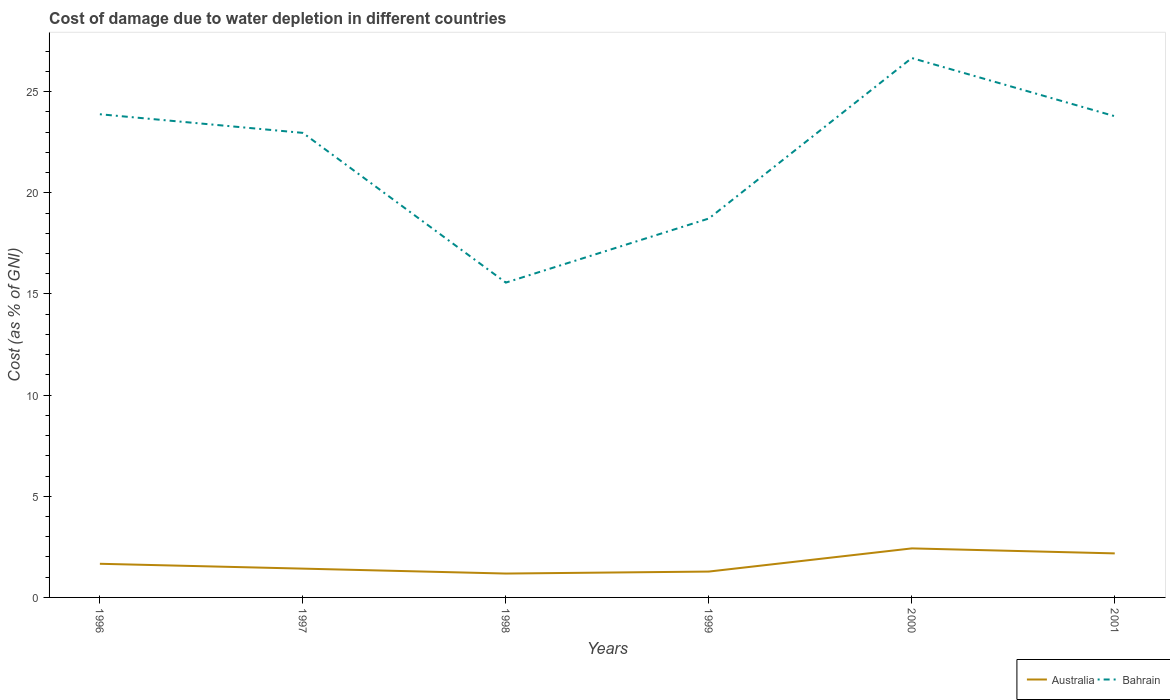How many different coloured lines are there?
Your answer should be compact. 2. Is the number of lines equal to the number of legend labels?
Give a very brief answer. Yes. Across all years, what is the maximum cost of damage caused due to water depletion in Australia?
Your response must be concise. 1.18. In which year was the cost of damage caused due to water depletion in Australia maximum?
Make the answer very short. 1998. What is the total cost of damage caused due to water depletion in Bahrain in the graph?
Keep it short and to the point. 0.92. What is the difference between the highest and the second highest cost of damage caused due to water depletion in Australia?
Give a very brief answer. 1.24. What is the difference between the highest and the lowest cost of damage caused due to water depletion in Bahrain?
Offer a terse response. 4. Is the cost of damage caused due to water depletion in Australia strictly greater than the cost of damage caused due to water depletion in Bahrain over the years?
Provide a short and direct response. Yes. How many lines are there?
Give a very brief answer. 2. How many years are there in the graph?
Provide a succinct answer. 6. Does the graph contain grids?
Make the answer very short. No. How many legend labels are there?
Provide a short and direct response. 2. What is the title of the graph?
Your answer should be compact. Cost of damage due to water depletion in different countries. What is the label or title of the X-axis?
Your answer should be compact. Years. What is the label or title of the Y-axis?
Give a very brief answer. Cost (as % of GNI). What is the Cost (as % of GNI) in Australia in 1996?
Ensure brevity in your answer.  1.66. What is the Cost (as % of GNI) in Bahrain in 1996?
Keep it short and to the point. 23.89. What is the Cost (as % of GNI) of Australia in 1997?
Give a very brief answer. 1.42. What is the Cost (as % of GNI) in Bahrain in 1997?
Keep it short and to the point. 22.96. What is the Cost (as % of GNI) in Australia in 1998?
Provide a short and direct response. 1.18. What is the Cost (as % of GNI) in Bahrain in 1998?
Provide a short and direct response. 15.56. What is the Cost (as % of GNI) of Australia in 1999?
Ensure brevity in your answer.  1.28. What is the Cost (as % of GNI) of Bahrain in 1999?
Provide a short and direct response. 18.73. What is the Cost (as % of GNI) in Australia in 2000?
Make the answer very short. 2.42. What is the Cost (as % of GNI) in Bahrain in 2000?
Keep it short and to the point. 26.66. What is the Cost (as % of GNI) in Australia in 2001?
Your answer should be very brief. 2.18. What is the Cost (as % of GNI) in Bahrain in 2001?
Offer a terse response. 23.79. Across all years, what is the maximum Cost (as % of GNI) of Australia?
Give a very brief answer. 2.42. Across all years, what is the maximum Cost (as % of GNI) of Bahrain?
Your answer should be compact. 26.66. Across all years, what is the minimum Cost (as % of GNI) of Australia?
Make the answer very short. 1.18. Across all years, what is the minimum Cost (as % of GNI) in Bahrain?
Provide a short and direct response. 15.56. What is the total Cost (as % of GNI) of Australia in the graph?
Offer a very short reply. 10.15. What is the total Cost (as % of GNI) in Bahrain in the graph?
Your answer should be compact. 131.6. What is the difference between the Cost (as % of GNI) of Australia in 1996 and that in 1997?
Your answer should be compact. 0.24. What is the difference between the Cost (as % of GNI) in Bahrain in 1996 and that in 1997?
Offer a very short reply. 0.92. What is the difference between the Cost (as % of GNI) of Australia in 1996 and that in 1998?
Keep it short and to the point. 0.48. What is the difference between the Cost (as % of GNI) of Bahrain in 1996 and that in 1998?
Ensure brevity in your answer.  8.32. What is the difference between the Cost (as % of GNI) of Australia in 1996 and that in 1999?
Provide a short and direct response. 0.38. What is the difference between the Cost (as % of GNI) of Bahrain in 1996 and that in 1999?
Ensure brevity in your answer.  5.15. What is the difference between the Cost (as % of GNI) in Australia in 1996 and that in 2000?
Offer a very short reply. -0.76. What is the difference between the Cost (as % of GNI) of Bahrain in 1996 and that in 2000?
Your answer should be compact. -2.78. What is the difference between the Cost (as % of GNI) of Australia in 1996 and that in 2001?
Give a very brief answer. -0.51. What is the difference between the Cost (as % of GNI) in Bahrain in 1996 and that in 2001?
Your response must be concise. 0.1. What is the difference between the Cost (as % of GNI) of Australia in 1997 and that in 1998?
Make the answer very short. 0.24. What is the difference between the Cost (as % of GNI) in Bahrain in 1997 and that in 1998?
Provide a short and direct response. 7.4. What is the difference between the Cost (as % of GNI) of Australia in 1997 and that in 1999?
Offer a very short reply. 0.15. What is the difference between the Cost (as % of GNI) of Bahrain in 1997 and that in 1999?
Make the answer very short. 4.23. What is the difference between the Cost (as % of GNI) of Australia in 1997 and that in 2000?
Give a very brief answer. -1. What is the difference between the Cost (as % of GNI) of Bahrain in 1997 and that in 2000?
Offer a terse response. -3.7. What is the difference between the Cost (as % of GNI) in Australia in 1997 and that in 2001?
Provide a succinct answer. -0.75. What is the difference between the Cost (as % of GNI) in Bahrain in 1997 and that in 2001?
Provide a short and direct response. -0.82. What is the difference between the Cost (as % of GNI) of Australia in 1998 and that in 1999?
Give a very brief answer. -0.1. What is the difference between the Cost (as % of GNI) of Bahrain in 1998 and that in 1999?
Offer a terse response. -3.17. What is the difference between the Cost (as % of GNI) in Australia in 1998 and that in 2000?
Your response must be concise. -1.24. What is the difference between the Cost (as % of GNI) in Bahrain in 1998 and that in 2000?
Offer a very short reply. -11.1. What is the difference between the Cost (as % of GNI) in Australia in 1998 and that in 2001?
Your response must be concise. -1. What is the difference between the Cost (as % of GNI) of Bahrain in 1998 and that in 2001?
Ensure brevity in your answer.  -8.23. What is the difference between the Cost (as % of GNI) of Australia in 1999 and that in 2000?
Make the answer very short. -1.15. What is the difference between the Cost (as % of GNI) in Bahrain in 1999 and that in 2000?
Provide a short and direct response. -7.93. What is the difference between the Cost (as % of GNI) in Australia in 1999 and that in 2001?
Give a very brief answer. -0.9. What is the difference between the Cost (as % of GNI) of Bahrain in 1999 and that in 2001?
Offer a very short reply. -5.06. What is the difference between the Cost (as % of GNI) of Australia in 2000 and that in 2001?
Give a very brief answer. 0.25. What is the difference between the Cost (as % of GNI) in Bahrain in 2000 and that in 2001?
Provide a short and direct response. 2.88. What is the difference between the Cost (as % of GNI) of Australia in 1996 and the Cost (as % of GNI) of Bahrain in 1997?
Ensure brevity in your answer.  -21.3. What is the difference between the Cost (as % of GNI) in Australia in 1996 and the Cost (as % of GNI) in Bahrain in 1998?
Your answer should be compact. -13.9. What is the difference between the Cost (as % of GNI) in Australia in 1996 and the Cost (as % of GNI) in Bahrain in 1999?
Your response must be concise. -17.07. What is the difference between the Cost (as % of GNI) of Australia in 1996 and the Cost (as % of GNI) of Bahrain in 2000?
Your answer should be very brief. -25. What is the difference between the Cost (as % of GNI) in Australia in 1996 and the Cost (as % of GNI) in Bahrain in 2001?
Your response must be concise. -22.13. What is the difference between the Cost (as % of GNI) in Australia in 1997 and the Cost (as % of GNI) in Bahrain in 1998?
Provide a succinct answer. -14.14. What is the difference between the Cost (as % of GNI) of Australia in 1997 and the Cost (as % of GNI) of Bahrain in 1999?
Your response must be concise. -17.31. What is the difference between the Cost (as % of GNI) of Australia in 1997 and the Cost (as % of GNI) of Bahrain in 2000?
Give a very brief answer. -25.24. What is the difference between the Cost (as % of GNI) in Australia in 1997 and the Cost (as % of GNI) in Bahrain in 2001?
Offer a very short reply. -22.36. What is the difference between the Cost (as % of GNI) of Australia in 1998 and the Cost (as % of GNI) of Bahrain in 1999?
Your answer should be compact. -17.55. What is the difference between the Cost (as % of GNI) of Australia in 1998 and the Cost (as % of GNI) of Bahrain in 2000?
Your response must be concise. -25.48. What is the difference between the Cost (as % of GNI) in Australia in 1998 and the Cost (as % of GNI) in Bahrain in 2001?
Offer a terse response. -22.61. What is the difference between the Cost (as % of GNI) of Australia in 1999 and the Cost (as % of GNI) of Bahrain in 2000?
Ensure brevity in your answer.  -25.39. What is the difference between the Cost (as % of GNI) in Australia in 1999 and the Cost (as % of GNI) in Bahrain in 2001?
Keep it short and to the point. -22.51. What is the difference between the Cost (as % of GNI) in Australia in 2000 and the Cost (as % of GNI) in Bahrain in 2001?
Make the answer very short. -21.36. What is the average Cost (as % of GNI) in Australia per year?
Provide a succinct answer. 1.69. What is the average Cost (as % of GNI) in Bahrain per year?
Give a very brief answer. 21.93. In the year 1996, what is the difference between the Cost (as % of GNI) of Australia and Cost (as % of GNI) of Bahrain?
Your response must be concise. -22.22. In the year 1997, what is the difference between the Cost (as % of GNI) of Australia and Cost (as % of GNI) of Bahrain?
Your response must be concise. -21.54. In the year 1998, what is the difference between the Cost (as % of GNI) in Australia and Cost (as % of GNI) in Bahrain?
Offer a very short reply. -14.38. In the year 1999, what is the difference between the Cost (as % of GNI) of Australia and Cost (as % of GNI) of Bahrain?
Provide a succinct answer. -17.45. In the year 2000, what is the difference between the Cost (as % of GNI) of Australia and Cost (as % of GNI) of Bahrain?
Give a very brief answer. -24.24. In the year 2001, what is the difference between the Cost (as % of GNI) of Australia and Cost (as % of GNI) of Bahrain?
Make the answer very short. -21.61. What is the ratio of the Cost (as % of GNI) in Australia in 1996 to that in 1997?
Your response must be concise. 1.17. What is the ratio of the Cost (as % of GNI) of Bahrain in 1996 to that in 1997?
Give a very brief answer. 1.04. What is the ratio of the Cost (as % of GNI) in Australia in 1996 to that in 1998?
Provide a short and direct response. 1.41. What is the ratio of the Cost (as % of GNI) in Bahrain in 1996 to that in 1998?
Make the answer very short. 1.53. What is the ratio of the Cost (as % of GNI) in Australia in 1996 to that in 1999?
Make the answer very short. 1.3. What is the ratio of the Cost (as % of GNI) of Bahrain in 1996 to that in 1999?
Offer a very short reply. 1.28. What is the ratio of the Cost (as % of GNI) of Australia in 1996 to that in 2000?
Keep it short and to the point. 0.69. What is the ratio of the Cost (as % of GNI) in Bahrain in 1996 to that in 2000?
Your answer should be compact. 0.9. What is the ratio of the Cost (as % of GNI) in Australia in 1996 to that in 2001?
Offer a very short reply. 0.76. What is the ratio of the Cost (as % of GNI) in Australia in 1997 to that in 1998?
Offer a terse response. 1.21. What is the ratio of the Cost (as % of GNI) of Bahrain in 1997 to that in 1998?
Your answer should be very brief. 1.48. What is the ratio of the Cost (as % of GNI) in Australia in 1997 to that in 1999?
Offer a very short reply. 1.11. What is the ratio of the Cost (as % of GNI) in Bahrain in 1997 to that in 1999?
Your answer should be very brief. 1.23. What is the ratio of the Cost (as % of GNI) of Australia in 1997 to that in 2000?
Offer a terse response. 0.59. What is the ratio of the Cost (as % of GNI) in Bahrain in 1997 to that in 2000?
Make the answer very short. 0.86. What is the ratio of the Cost (as % of GNI) of Australia in 1997 to that in 2001?
Your answer should be very brief. 0.65. What is the ratio of the Cost (as % of GNI) of Bahrain in 1997 to that in 2001?
Make the answer very short. 0.97. What is the ratio of the Cost (as % of GNI) of Australia in 1998 to that in 1999?
Provide a succinct answer. 0.92. What is the ratio of the Cost (as % of GNI) of Bahrain in 1998 to that in 1999?
Make the answer very short. 0.83. What is the ratio of the Cost (as % of GNI) of Australia in 1998 to that in 2000?
Your response must be concise. 0.49. What is the ratio of the Cost (as % of GNI) of Bahrain in 1998 to that in 2000?
Offer a terse response. 0.58. What is the ratio of the Cost (as % of GNI) in Australia in 1998 to that in 2001?
Offer a very short reply. 0.54. What is the ratio of the Cost (as % of GNI) of Bahrain in 1998 to that in 2001?
Offer a very short reply. 0.65. What is the ratio of the Cost (as % of GNI) of Australia in 1999 to that in 2000?
Provide a succinct answer. 0.53. What is the ratio of the Cost (as % of GNI) of Bahrain in 1999 to that in 2000?
Keep it short and to the point. 0.7. What is the ratio of the Cost (as % of GNI) in Australia in 1999 to that in 2001?
Offer a very short reply. 0.59. What is the ratio of the Cost (as % of GNI) in Bahrain in 1999 to that in 2001?
Provide a short and direct response. 0.79. What is the ratio of the Cost (as % of GNI) of Australia in 2000 to that in 2001?
Your answer should be very brief. 1.11. What is the ratio of the Cost (as % of GNI) in Bahrain in 2000 to that in 2001?
Give a very brief answer. 1.12. What is the difference between the highest and the second highest Cost (as % of GNI) in Australia?
Provide a short and direct response. 0.25. What is the difference between the highest and the second highest Cost (as % of GNI) of Bahrain?
Keep it short and to the point. 2.78. What is the difference between the highest and the lowest Cost (as % of GNI) of Australia?
Offer a terse response. 1.24. What is the difference between the highest and the lowest Cost (as % of GNI) of Bahrain?
Provide a succinct answer. 11.1. 